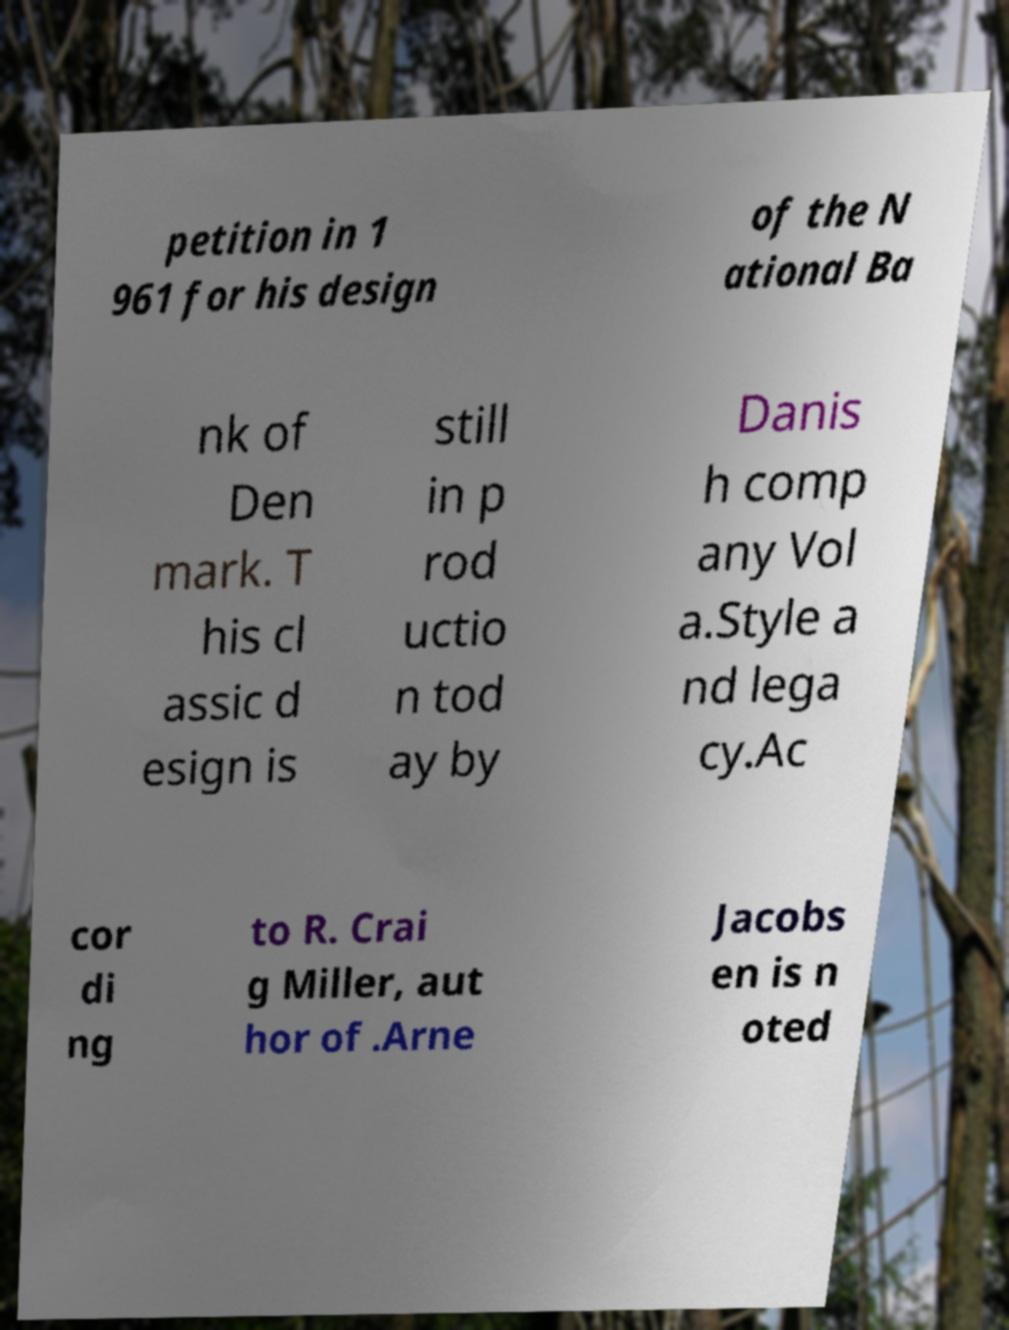Can you read and provide the text displayed in the image?This photo seems to have some interesting text. Can you extract and type it out for me? petition in 1 961 for his design of the N ational Ba nk of Den mark. T his cl assic d esign is still in p rod uctio n tod ay by Danis h comp any Vol a.Style a nd lega cy.Ac cor di ng to R. Crai g Miller, aut hor of .Arne Jacobs en is n oted 